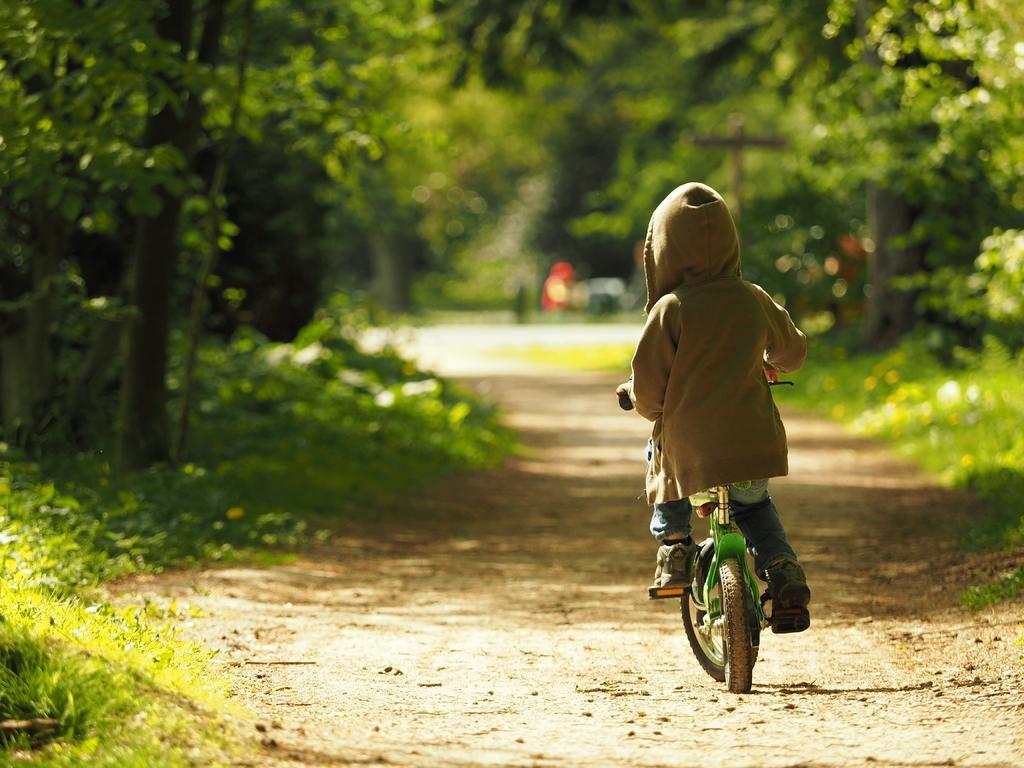How would you summarize this image in a sentence or two? He is riding a bicycle. He's holding a handle. He's wearing a colorful shirt. We can see in the background there is a trees and road. 